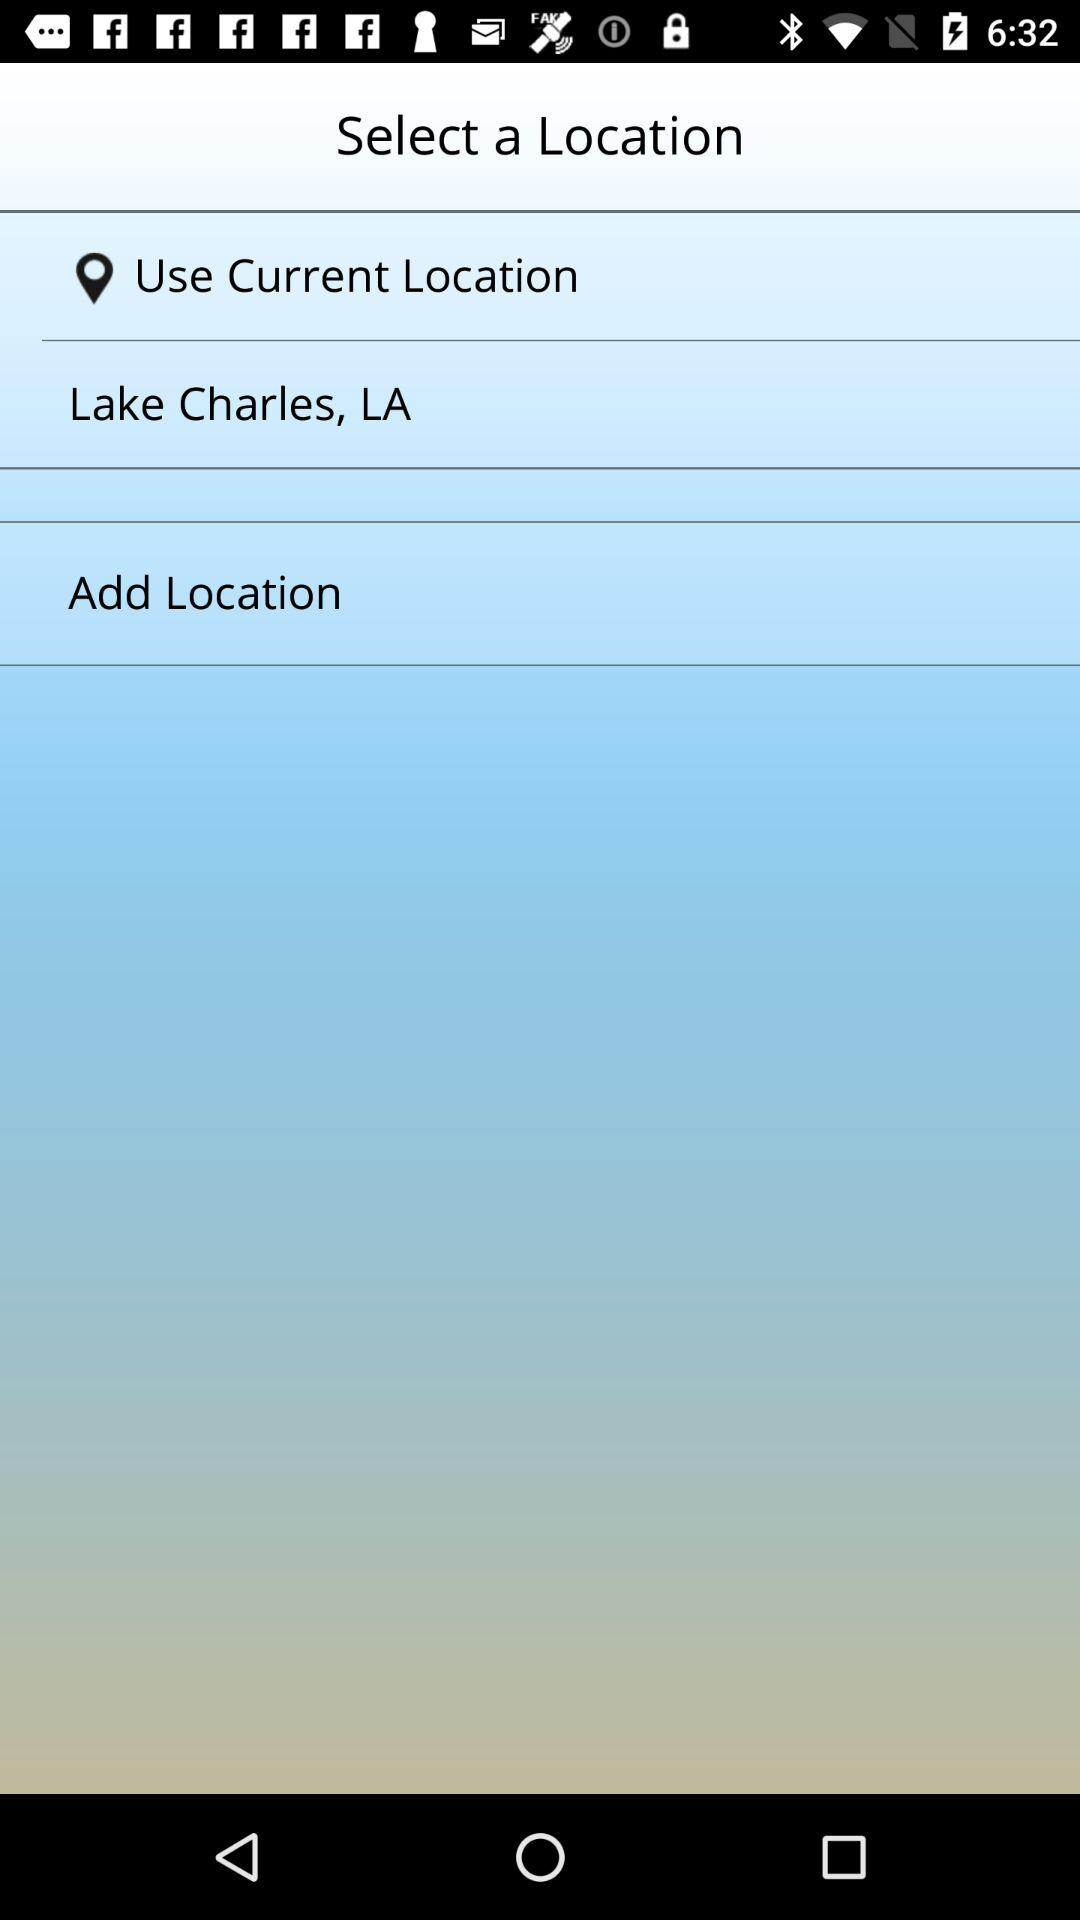What is the mentioned location? The mentioned location is Lake Charles, LA. 